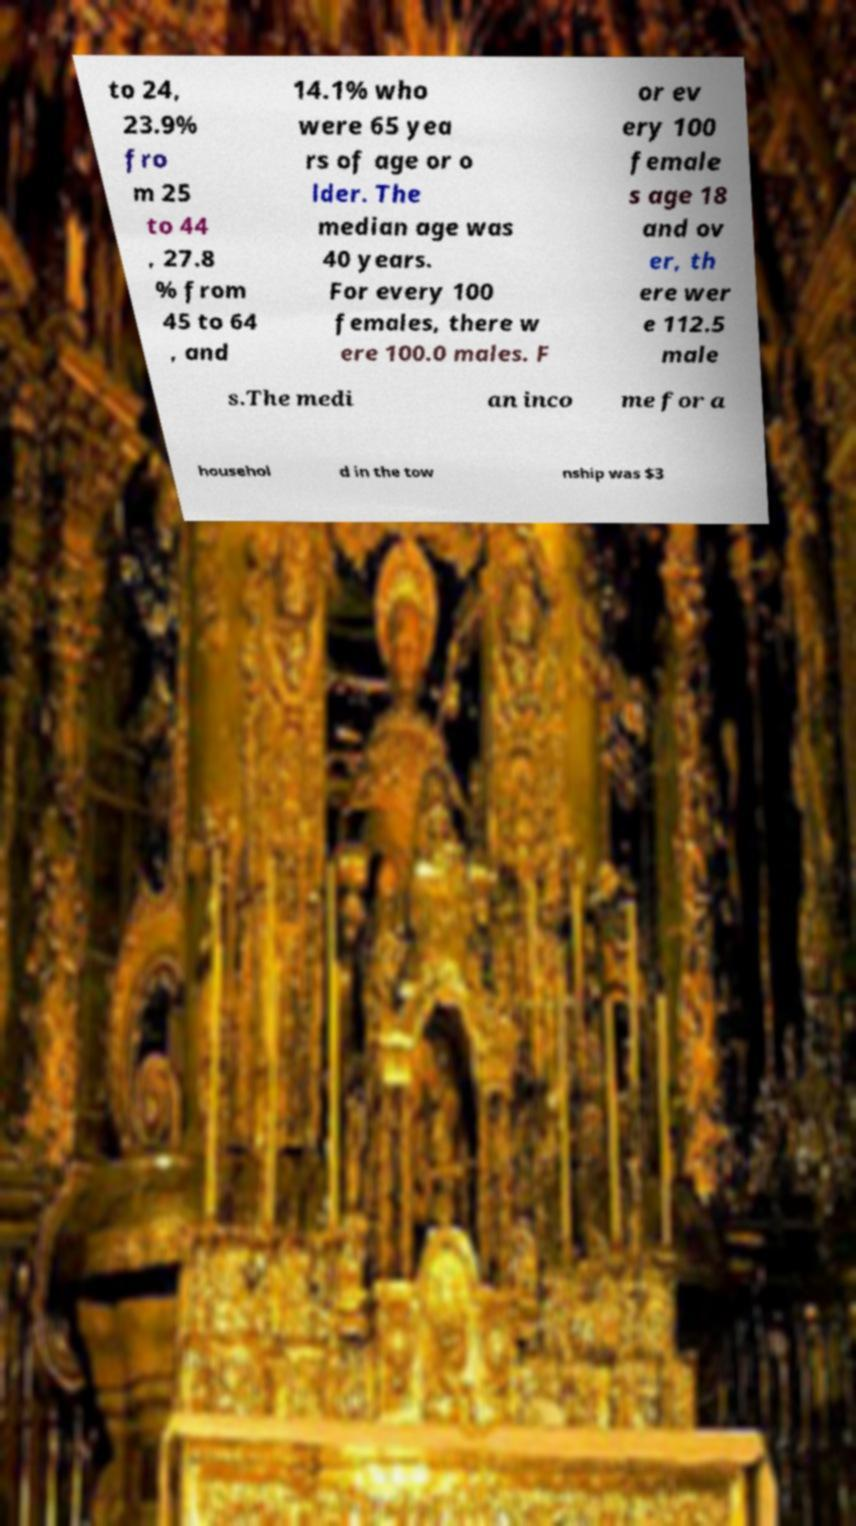Please identify and transcribe the text found in this image. to 24, 23.9% fro m 25 to 44 , 27.8 % from 45 to 64 , and 14.1% who were 65 yea rs of age or o lder. The median age was 40 years. For every 100 females, there w ere 100.0 males. F or ev ery 100 female s age 18 and ov er, th ere wer e 112.5 male s.The medi an inco me for a househol d in the tow nship was $3 